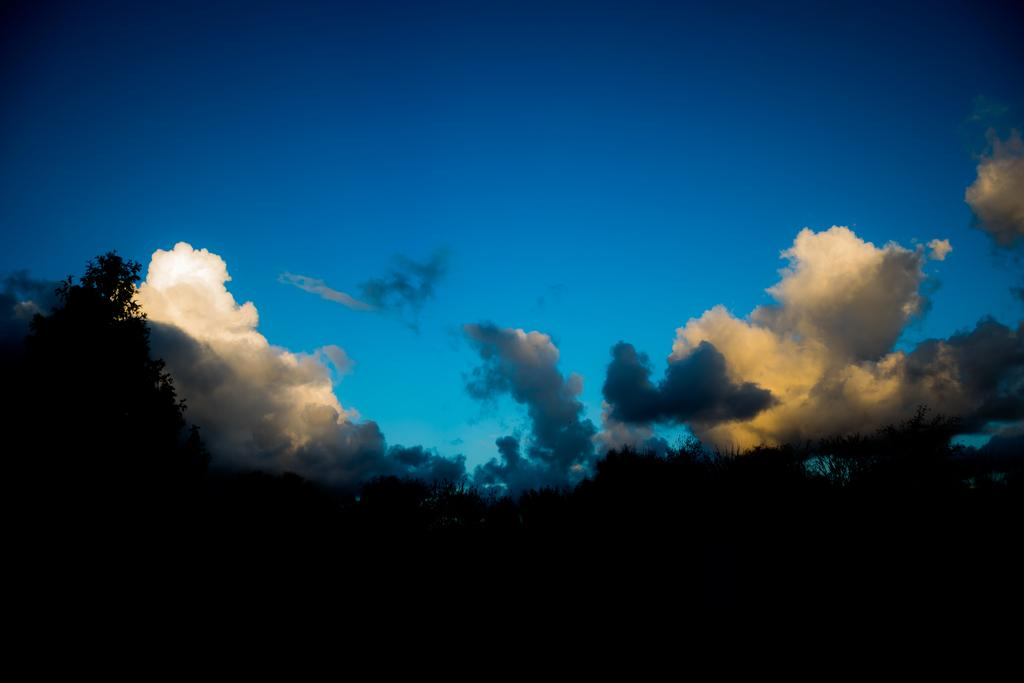What is the main feature in the foreground of the image? There are many trees in the foreground of the image. What can be seen in the middle of the image? There are many clouds in the middle of the image. What is visible in the background of the image? The sky is visible in the background of the image. How many servants are visible in the image? There are no servants present in the image. Is it raining in the image? There is no indication of rain in the image, as it primarily features trees, clouds, and the sky. 